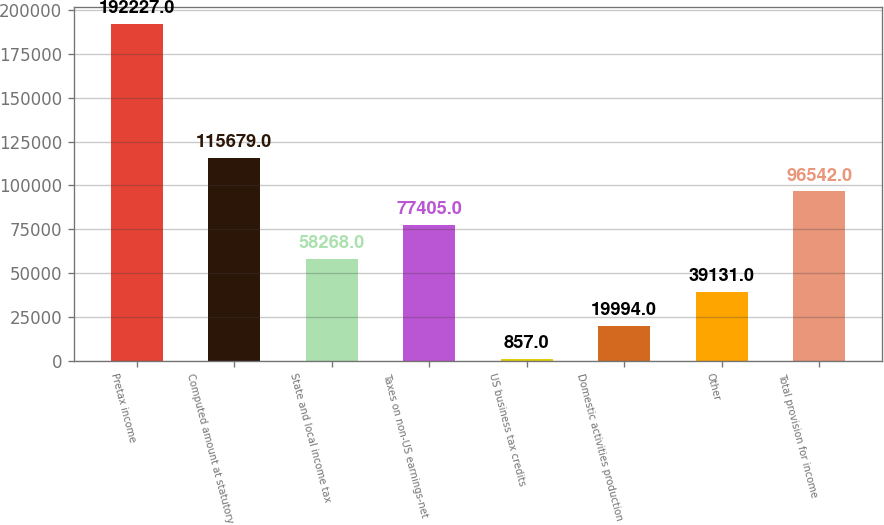Convert chart. <chart><loc_0><loc_0><loc_500><loc_500><bar_chart><fcel>Pretax income<fcel>Computed amount at statutory<fcel>State and local income tax<fcel>Taxes on non-US earnings-net<fcel>US business tax credits<fcel>Domestic activities production<fcel>Other<fcel>Total provision for income<nl><fcel>192227<fcel>115679<fcel>58268<fcel>77405<fcel>857<fcel>19994<fcel>39131<fcel>96542<nl></chart> 